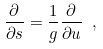<formula> <loc_0><loc_0><loc_500><loc_500>\frac { \partial } { \partial s } = \frac { 1 } { g } \frac { \partial } { \partial u } \ ,</formula> 